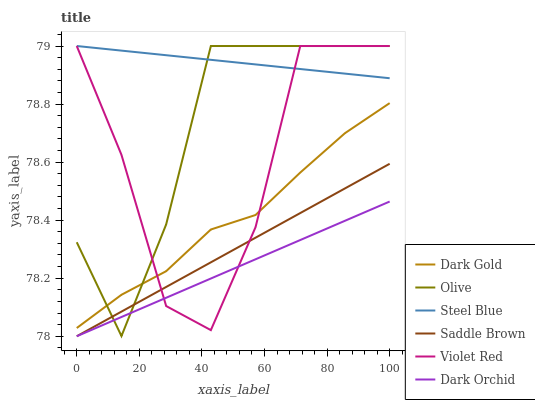Does Dark Orchid have the minimum area under the curve?
Answer yes or no. Yes. Does Steel Blue have the maximum area under the curve?
Answer yes or no. Yes. Does Dark Gold have the minimum area under the curve?
Answer yes or no. No. Does Dark Gold have the maximum area under the curve?
Answer yes or no. No. Is Dark Orchid the smoothest?
Answer yes or no. Yes. Is Violet Red the roughest?
Answer yes or no. Yes. Is Dark Gold the smoothest?
Answer yes or no. No. Is Dark Gold the roughest?
Answer yes or no. No. Does Dark Orchid have the lowest value?
Answer yes or no. Yes. Does Dark Gold have the lowest value?
Answer yes or no. No. Does Olive have the highest value?
Answer yes or no. Yes. Does Dark Gold have the highest value?
Answer yes or no. No. Is Dark Orchid less than Steel Blue?
Answer yes or no. Yes. Is Steel Blue greater than Saddle Brown?
Answer yes or no. Yes. Does Olive intersect Saddle Brown?
Answer yes or no. Yes. Is Olive less than Saddle Brown?
Answer yes or no. No. Is Olive greater than Saddle Brown?
Answer yes or no. No. Does Dark Orchid intersect Steel Blue?
Answer yes or no. No. 